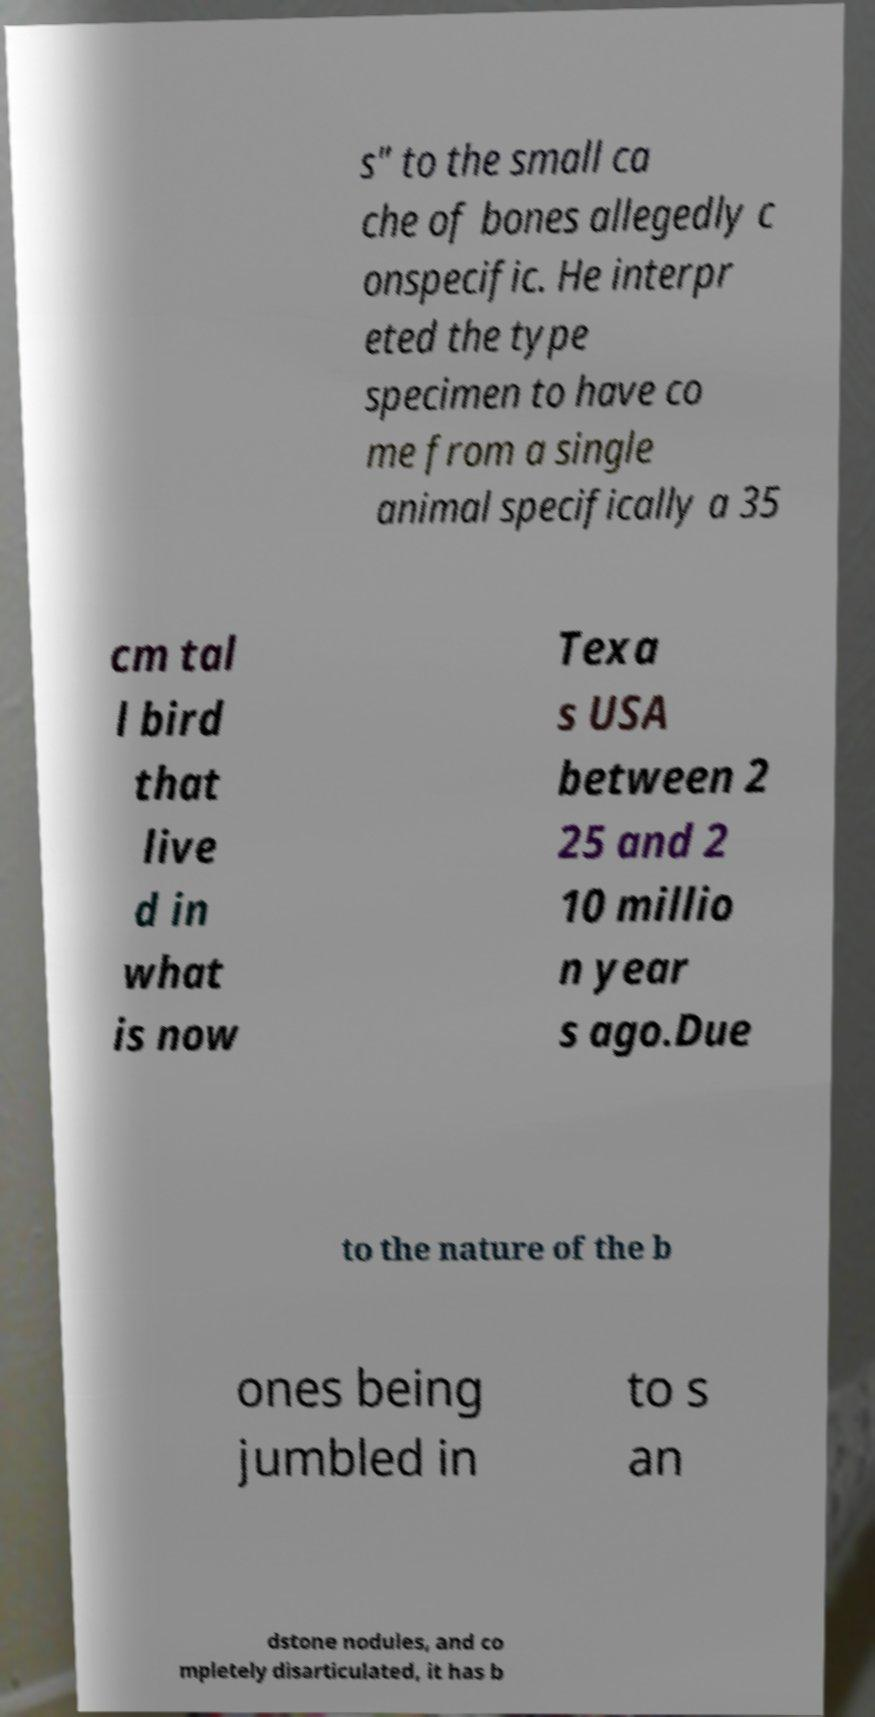Could you assist in decoding the text presented in this image and type it out clearly? s" to the small ca che of bones allegedly c onspecific. He interpr eted the type specimen to have co me from a single animal specifically a 35 cm tal l bird that live d in what is now Texa s USA between 2 25 and 2 10 millio n year s ago.Due to the nature of the b ones being jumbled in to s an dstone nodules, and co mpletely disarticulated, it has b 